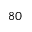<formula> <loc_0><loc_0><loc_500><loc_500>8 0</formula> 